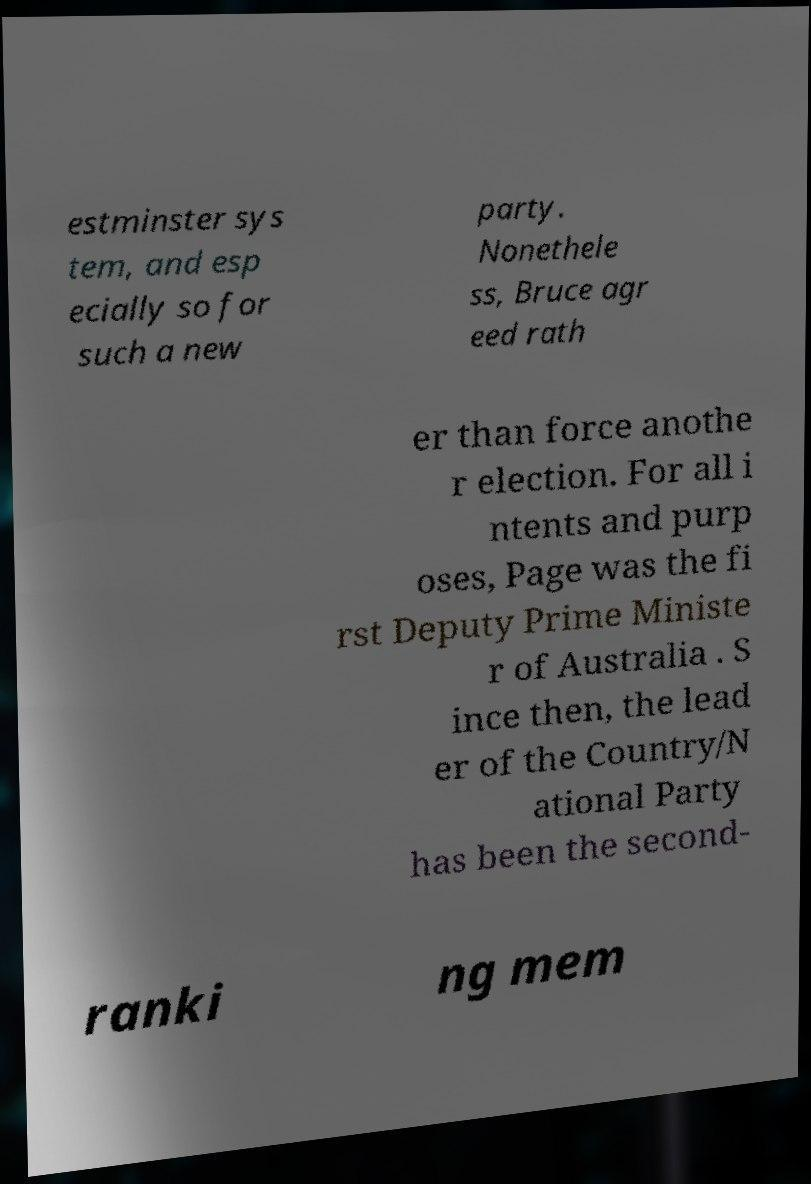Could you assist in decoding the text presented in this image and type it out clearly? estminster sys tem, and esp ecially so for such a new party. Nonethele ss, Bruce agr eed rath er than force anothe r election. For all i ntents and purp oses, Page was the fi rst Deputy Prime Ministe r of Australia . S ince then, the lead er of the Country/N ational Party has been the second- ranki ng mem 